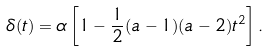<formula> <loc_0><loc_0><loc_500><loc_500>\delta ( t ) = \alpha \left [ 1 - \frac { 1 } { 2 } ( a - 1 ) ( a - 2 ) t ^ { 2 } \right ] .</formula> 